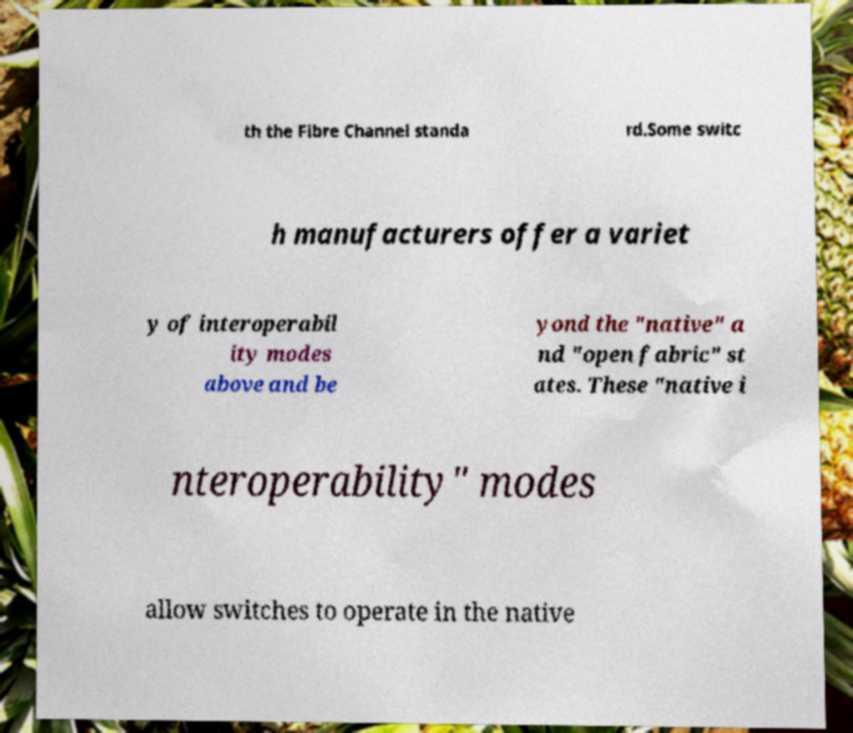Please read and relay the text visible in this image. What does it say? th the Fibre Channel standa rd.Some switc h manufacturers offer a variet y of interoperabil ity modes above and be yond the "native" a nd "open fabric" st ates. These "native i nteroperability" modes allow switches to operate in the native 